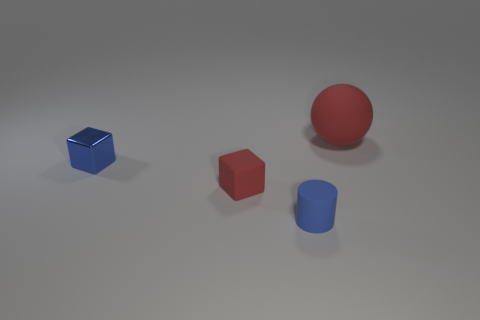Are there any other things that have the same size as the red sphere?
Make the answer very short. No. Are there any other things that are made of the same material as the blue block?
Your response must be concise. No. There is a tiny thing that is the same color as the rubber cylinder; what shape is it?
Offer a terse response. Cube. What number of objects are either cubes on the right side of the small blue metallic block or cyan rubber blocks?
Ensure brevity in your answer.  1. What is the size of the blue cylinder that is made of the same material as the sphere?
Ensure brevity in your answer.  Small. Are there more blue things that are behind the blue matte thing than blue rubber cylinders?
Your answer should be very brief. No. There is a tiny blue metal thing; is its shape the same as the matte thing to the right of the small blue rubber cylinder?
Make the answer very short. No. How many small things are either brown shiny cylinders or red matte blocks?
Provide a succinct answer. 1. There is a thing that is the same color as the sphere; what size is it?
Ensure brevity in your answer.  Small. The block that is behind the red thing that is in front of the red rubber ball is what color?
Offer a very short reply. Blue. 